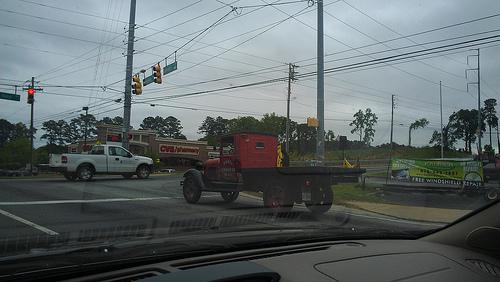Question: why is the car stopped?
Choices:
A. No gas.
B. Broke down.
C. Flat tire.
D. Because the light is red.
Answer with the letter. Answer: D Question: what color is the road?
Choices:
A. Black.
B. Grey.
C. Red.
D. Tan.
Answer with the letter. Answer: A 